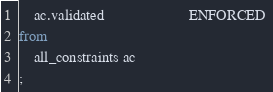<code> <loc_0><loc_0><loc_500><loc_500><_SQL_>    ac.validated                      ENFORCED 
from
    all_constraints ac
;
</code> 